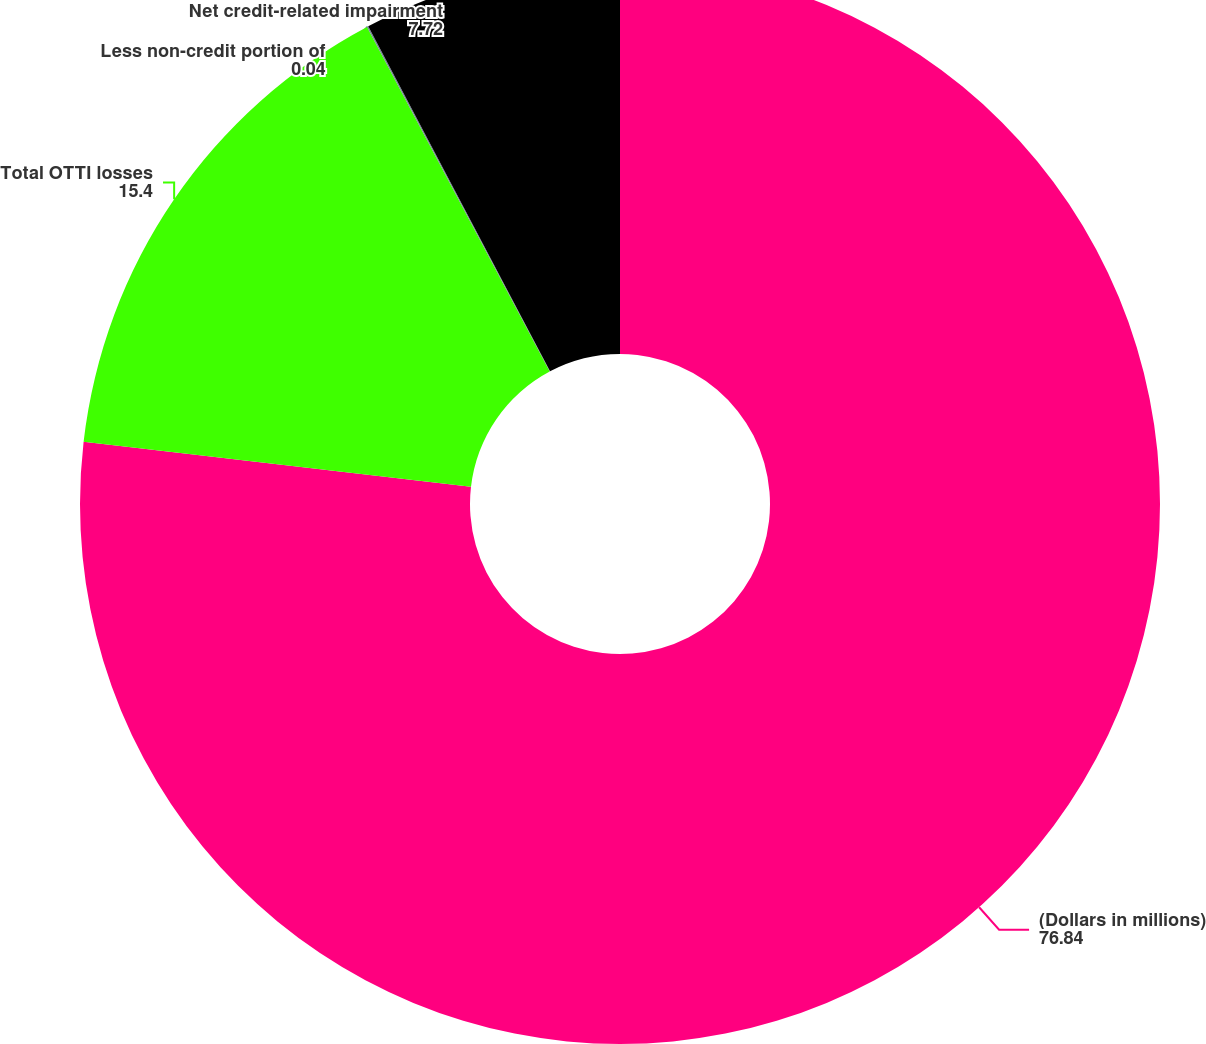<chart> <loc_0><loc_0><loc_500><loc_500><pie_chart><fcel>(Dollars in millions)<fcel>Total OTTI losses<fcel>Less non-credit portion of<fcel>Net credit-related impairment<nl><fcel>76.84%<fcel>15.4%<fcel>0.04%<fcel>7.72%<nl></chart> 